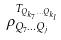<formula> <loc_0><loc_0><loc_500><loc_500>\rho _ { Q _ { 7 } \dots Q _ { j } } ^ { T _ { Q _ { k _ { 7 } } \dots Q _ { k _ { l } } } }</formula> 